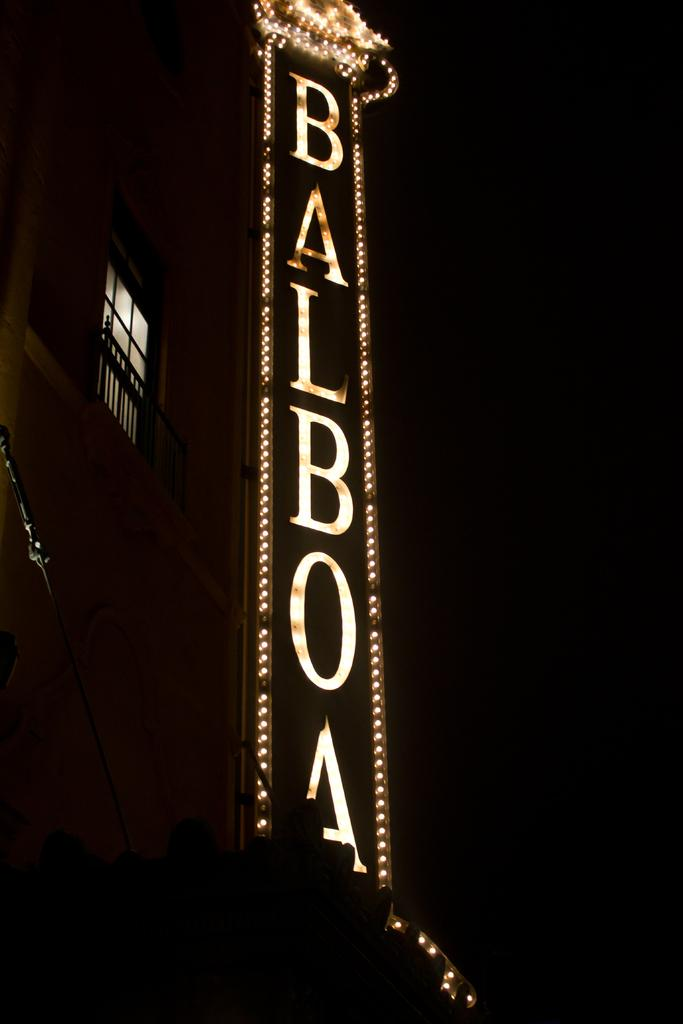What is the main feature in the center of the image? There is a banner with text in the center of the image. What can be seen on the left side of the image? There is a window on the left side of the image. Are there any light sources visible in the image? Yes, there are lights visible in the image. What type of sail can be seen in the image? There is no sail present in the image. What form does the banner take in the image? The banner is in the form of a rectangular piece of material with text on it. 